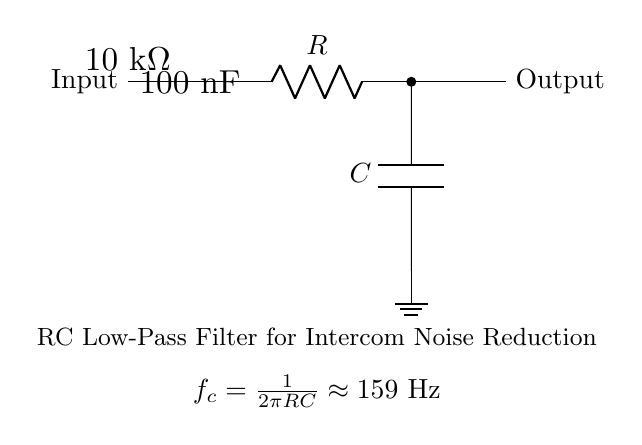What type of filter is this circuit? The circuit is an RC low-pass filter, as indicated by the designation of the resistor and capacitor in the diagram. The components are connected in such a way that they allow low-frequency signals to pass while attenuating high-frequency signals.
Answer: RC low-pass filter What is the value of the resistor used in this circuit? The resistor value is explicitly stated in the circuit diagram as 10 kΩ. This information is directly labeled on the resistor in the visualization.
Answer: 10 kΩ What is the cutoff frequency of this RC low-pass filter? The cutoff frequency is calculated using the formula f_c = 1 / (2πRC). Substituting the given values for R (10 kΩ) and C (100 nF), we find the approximate cutoff frequency to be around 159 Hz, as noted in the circuit diagram.
Answer: 159 Hz How many components are in this circuit? The circuit consists of two major components: one resistor and one capacitor. The connections between them are also part of the circuit but do not count as separate components.
Answer: 2 What happens to high-frequency signals in this filter? High-frequency signals are attenuated in this RC low-pass filter. The configuration allows lower frequencies to pass while the higher frequencies do not, leading to a reduction of noise in intercom systems.
Answer: Attenuated Why is this circuit used in intercom systems? This circuit is used in intercom systems to reduce noise because it effectively eliminates high-frequency interference, allowing for clearer audio transmission. The design specifically tackles unwanted noise, improving communication quality.
Answer: To reduce noise 